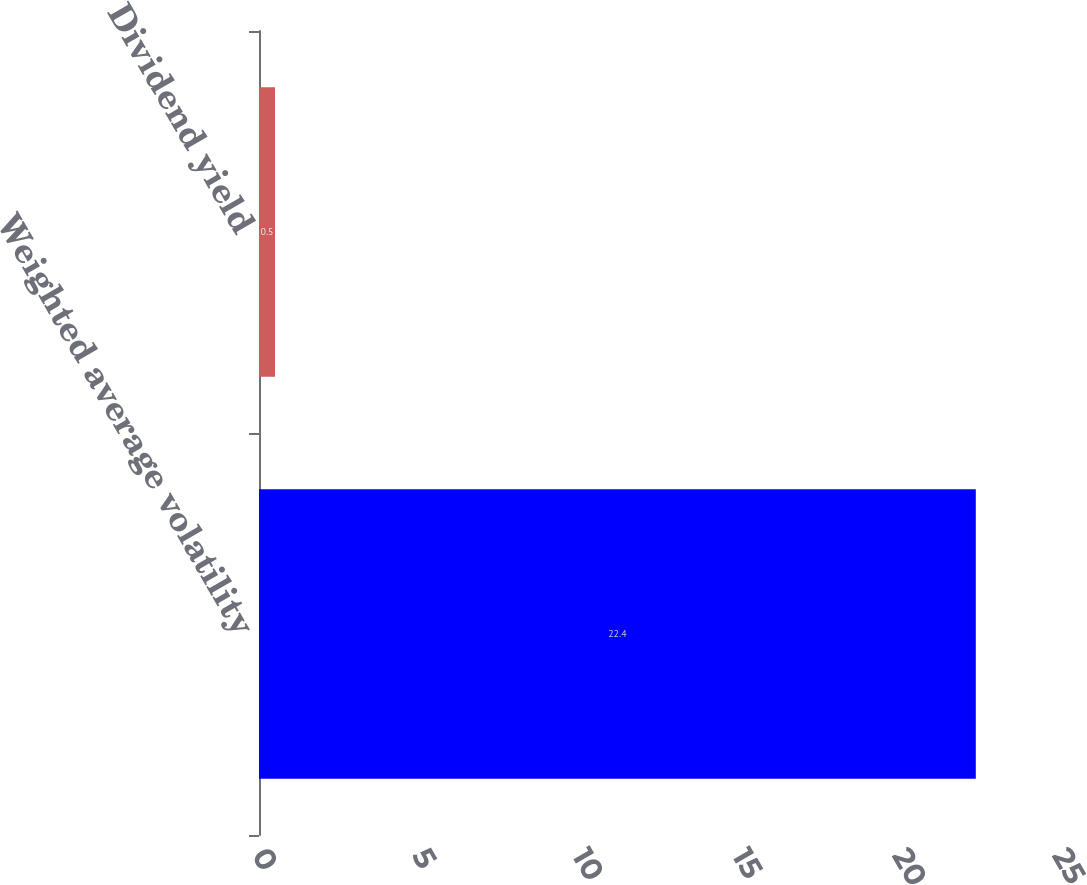Convert chart. <chart><loc_0><loc_0><loc_500><loc_500><bar_chart><fcel>Weighted average volatility<fcel>Dividend yield<nl><fcel>22.4<fcel>0.5<nl></chart> 